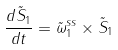<formula> <loc_0><loc_0><loc_500><loc_500>\frac { d { \tilde { S } } _ { 1 } } { d t } = { \tilde { \omega } } ^ { s s } _ { 1 } \times { \tilde { S } } _ { 1 }</formula> 